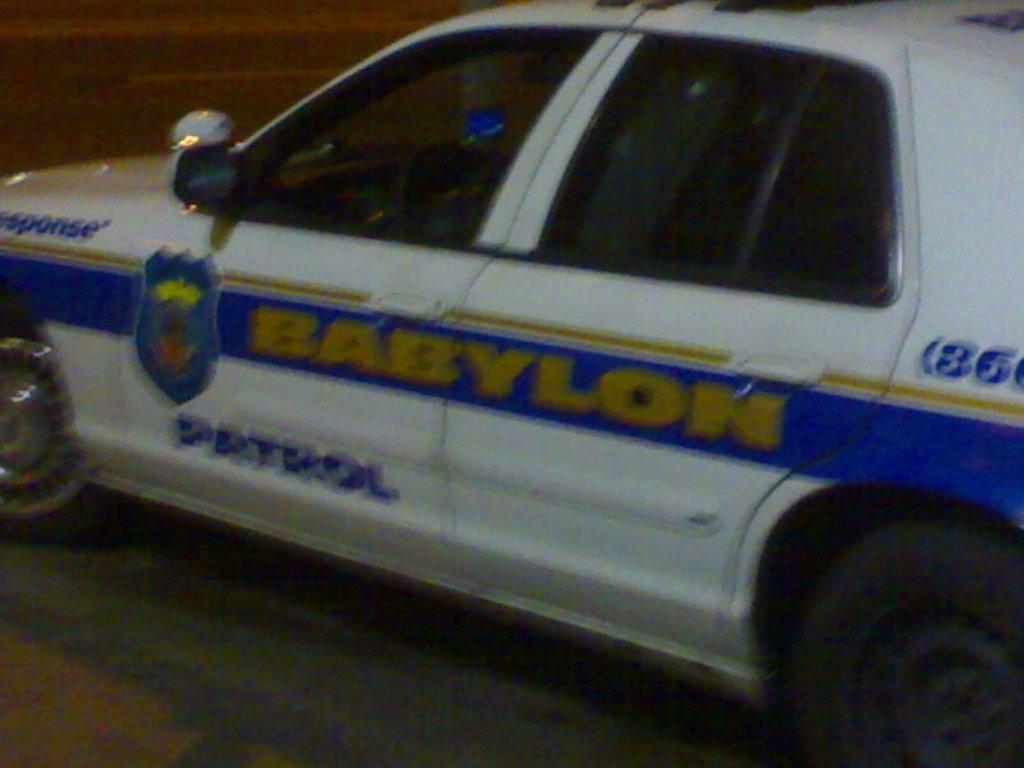Please provide a concise description of this image. In this image we can see there is a vehicle moving on the road. 